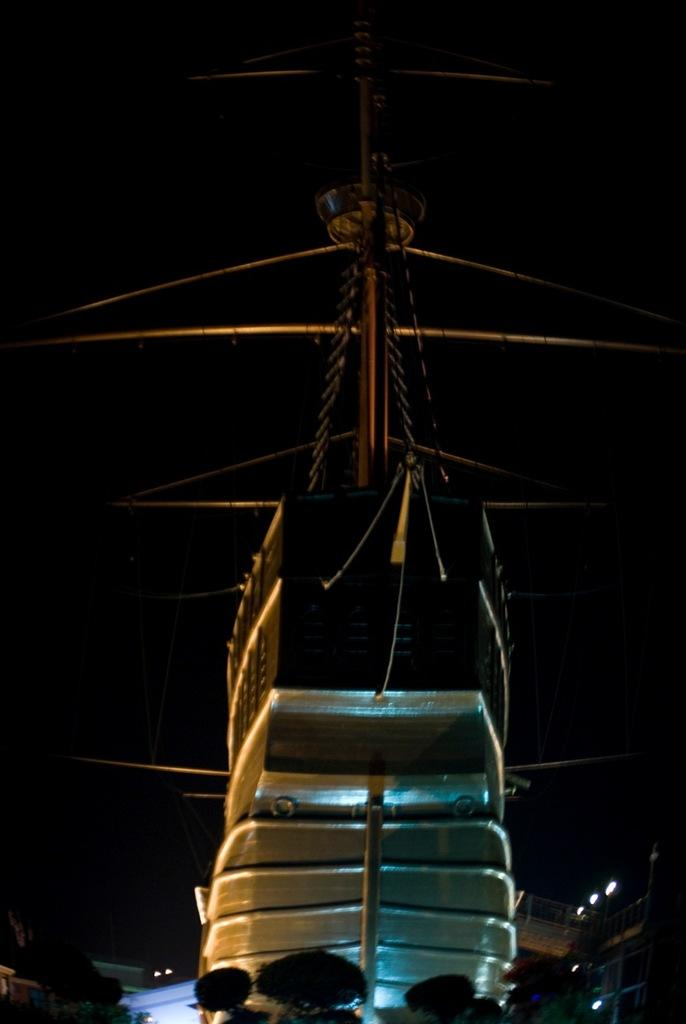What is the main subject of the image? The main subject of the image is a ship. What can be seen in the bottom right corner of the image? There are light poles in the bottom right corner of the image. What type of vegetation is visible at the bottom of the image? There are trees at the bottom of the image. How would you describe the overall lighting in the image? The background of the image is dark. What type of grape is being used as a prop in the image? There is no grape present in the image. What class of students is attending the event in the image? There is no event or students present in the image. 